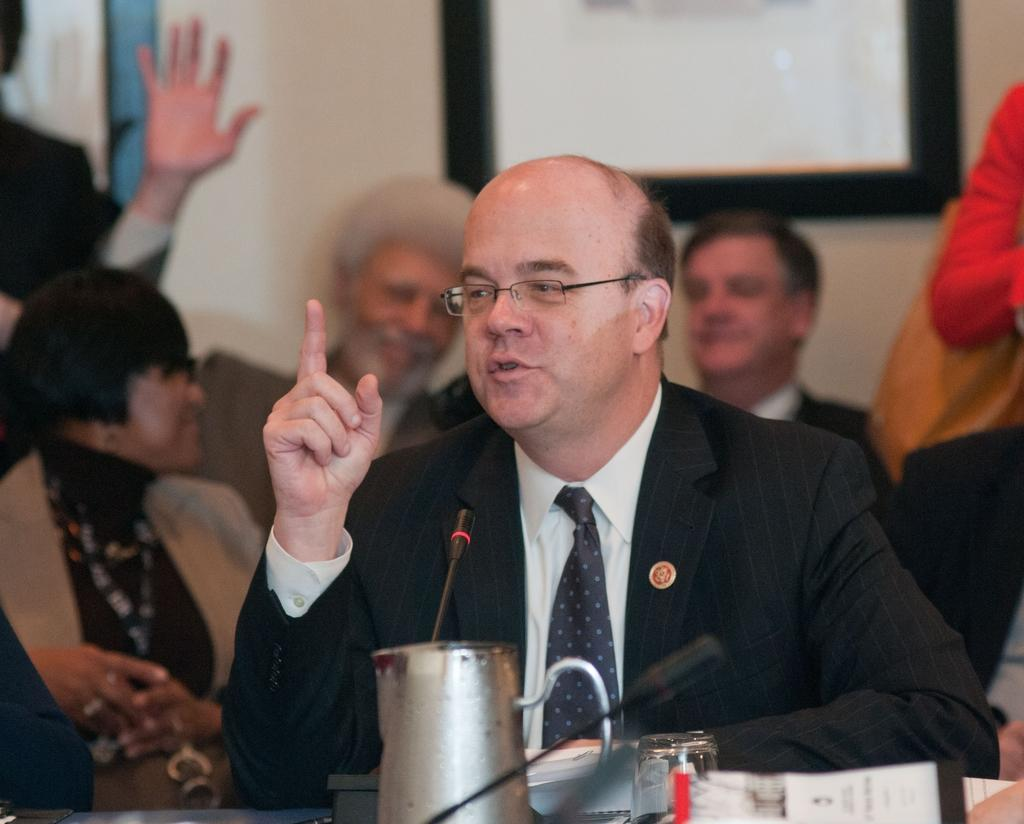What is the person in the image doing? The person is sitting in the image. Where is the person sitting in relation to the table? The person is in front of the table. What can be seen on the table in the image? The table has a jar, a microphone, papers, and other objects on it. Are there any people visible behind the sitting person? Yes, there are people behind the sitting person. What is attached to the wall in the image? There is a frame attached to the wall. Can you see a tiger swimming in the ocean in the image? No, there is no tiger or ocean present in the image. 